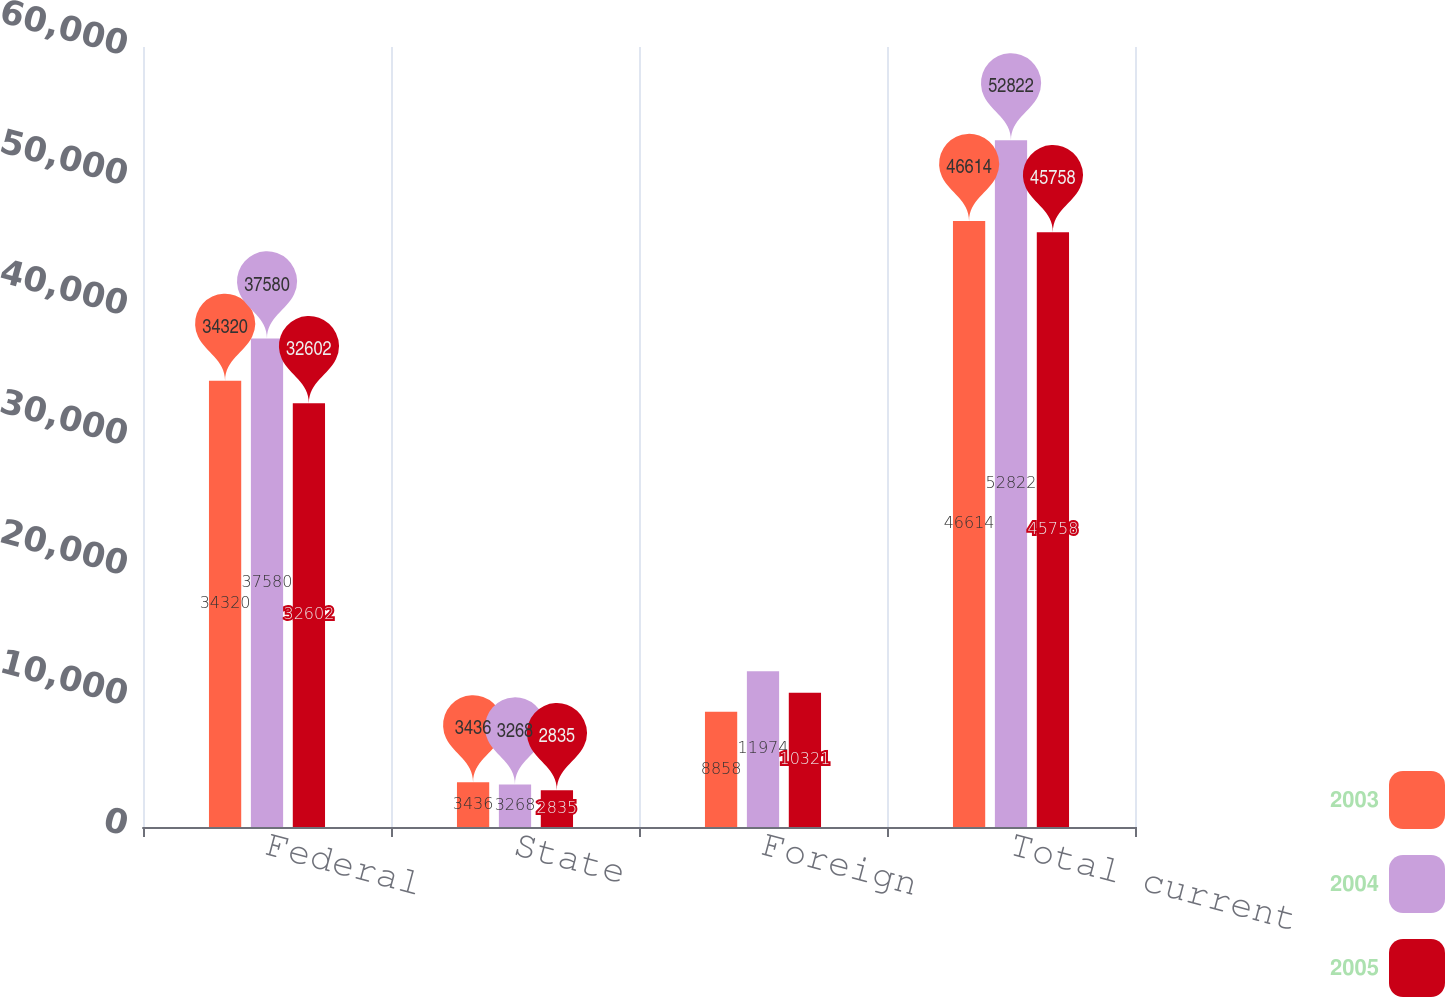Convert chart to OTSL. <chart><loc_0><loc_0><loc_500><loc_500><stacked_bar_chart><ecel><fcel>Federal<fcel>State<fcel>Foreign<fcel>Total current<nl><fcel>2003<fcel>34320<fcel>3436<fcel>8858<fcel>46614<nl><fcel>2004<fcel>37580<fcel>3268<fcel>11974<fcel>52822<nl><fcel>2005<fcel>32602<fcel>2835<fcel>10321<fcel>45758<nl></chart> 